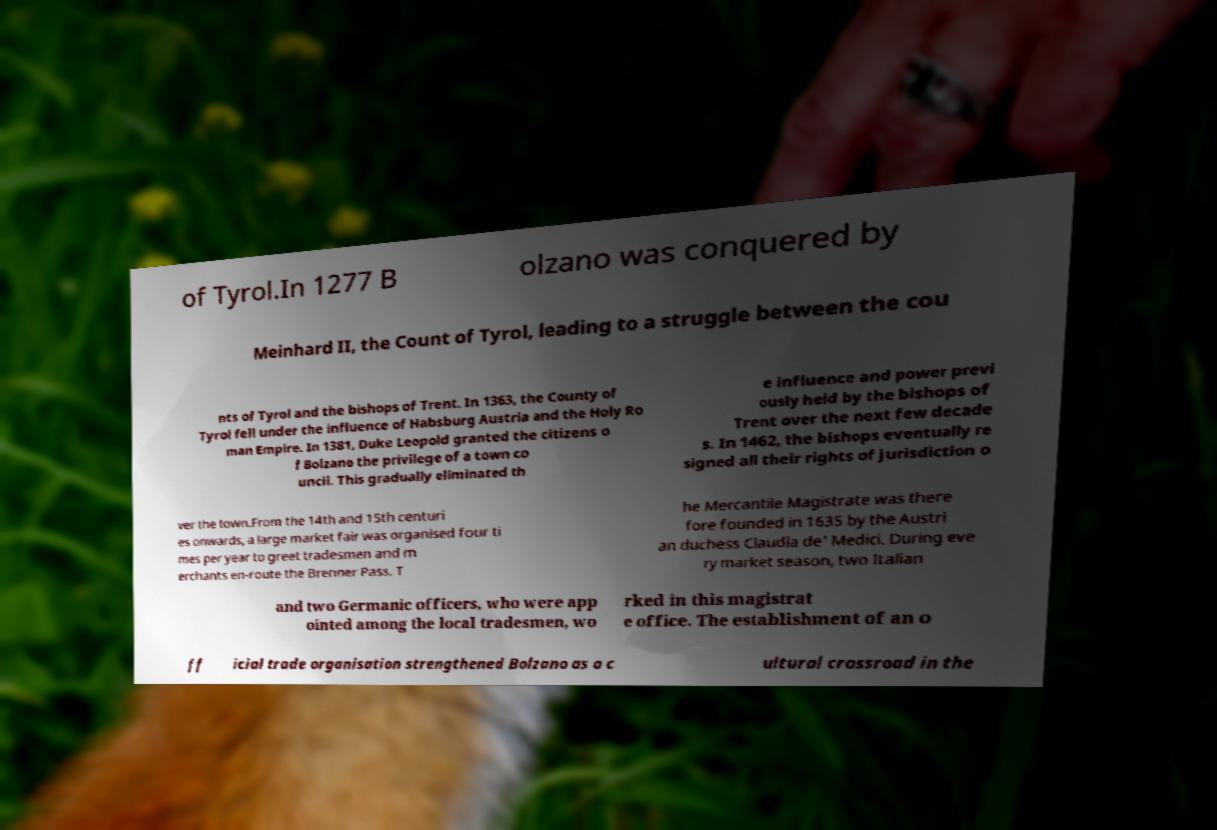Please identify and transcribe the text found in this image. of Tyrol.In 1277 B olzano was conquered by Meinhard II, the Count of Tyrol, leading to a struggle between the cou nts of Tyrol and the bishops of Trent. In 1363, the County of Tyrol fell under the influence of Habsburg Austria and the Holy Ro man Empire. In 1381, Duke Leopold granted the citizens o f Bolzano the privilege of a town co uncil. This gradually eliminated th e influence and power previ ously held by the bishops of Trent over the next few decade s. In 1462, the bishops eventually re signed all their rights of jurisdiction o ver the town.From the 14th and 15th centuri es onwards, a large market fair was organised four ti mes per year to greet tradesmen and m erchants en-route the Brenner Pass. T he Mercantile Magistrate was there fore founded in 1635 by the Austri an duchess Claudia de' Medici. During eve ry market season, two Italian and two Germanic officers, who were app ointed among the local tradesmen, wo rked in this magistrat e office. The establishment of an o ff icial trade organisation strengthened Bolzano as a c ultural crossroad in the 